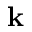<formula> <loc_0><loc_0><loc_500><loc_500>k</formula> 